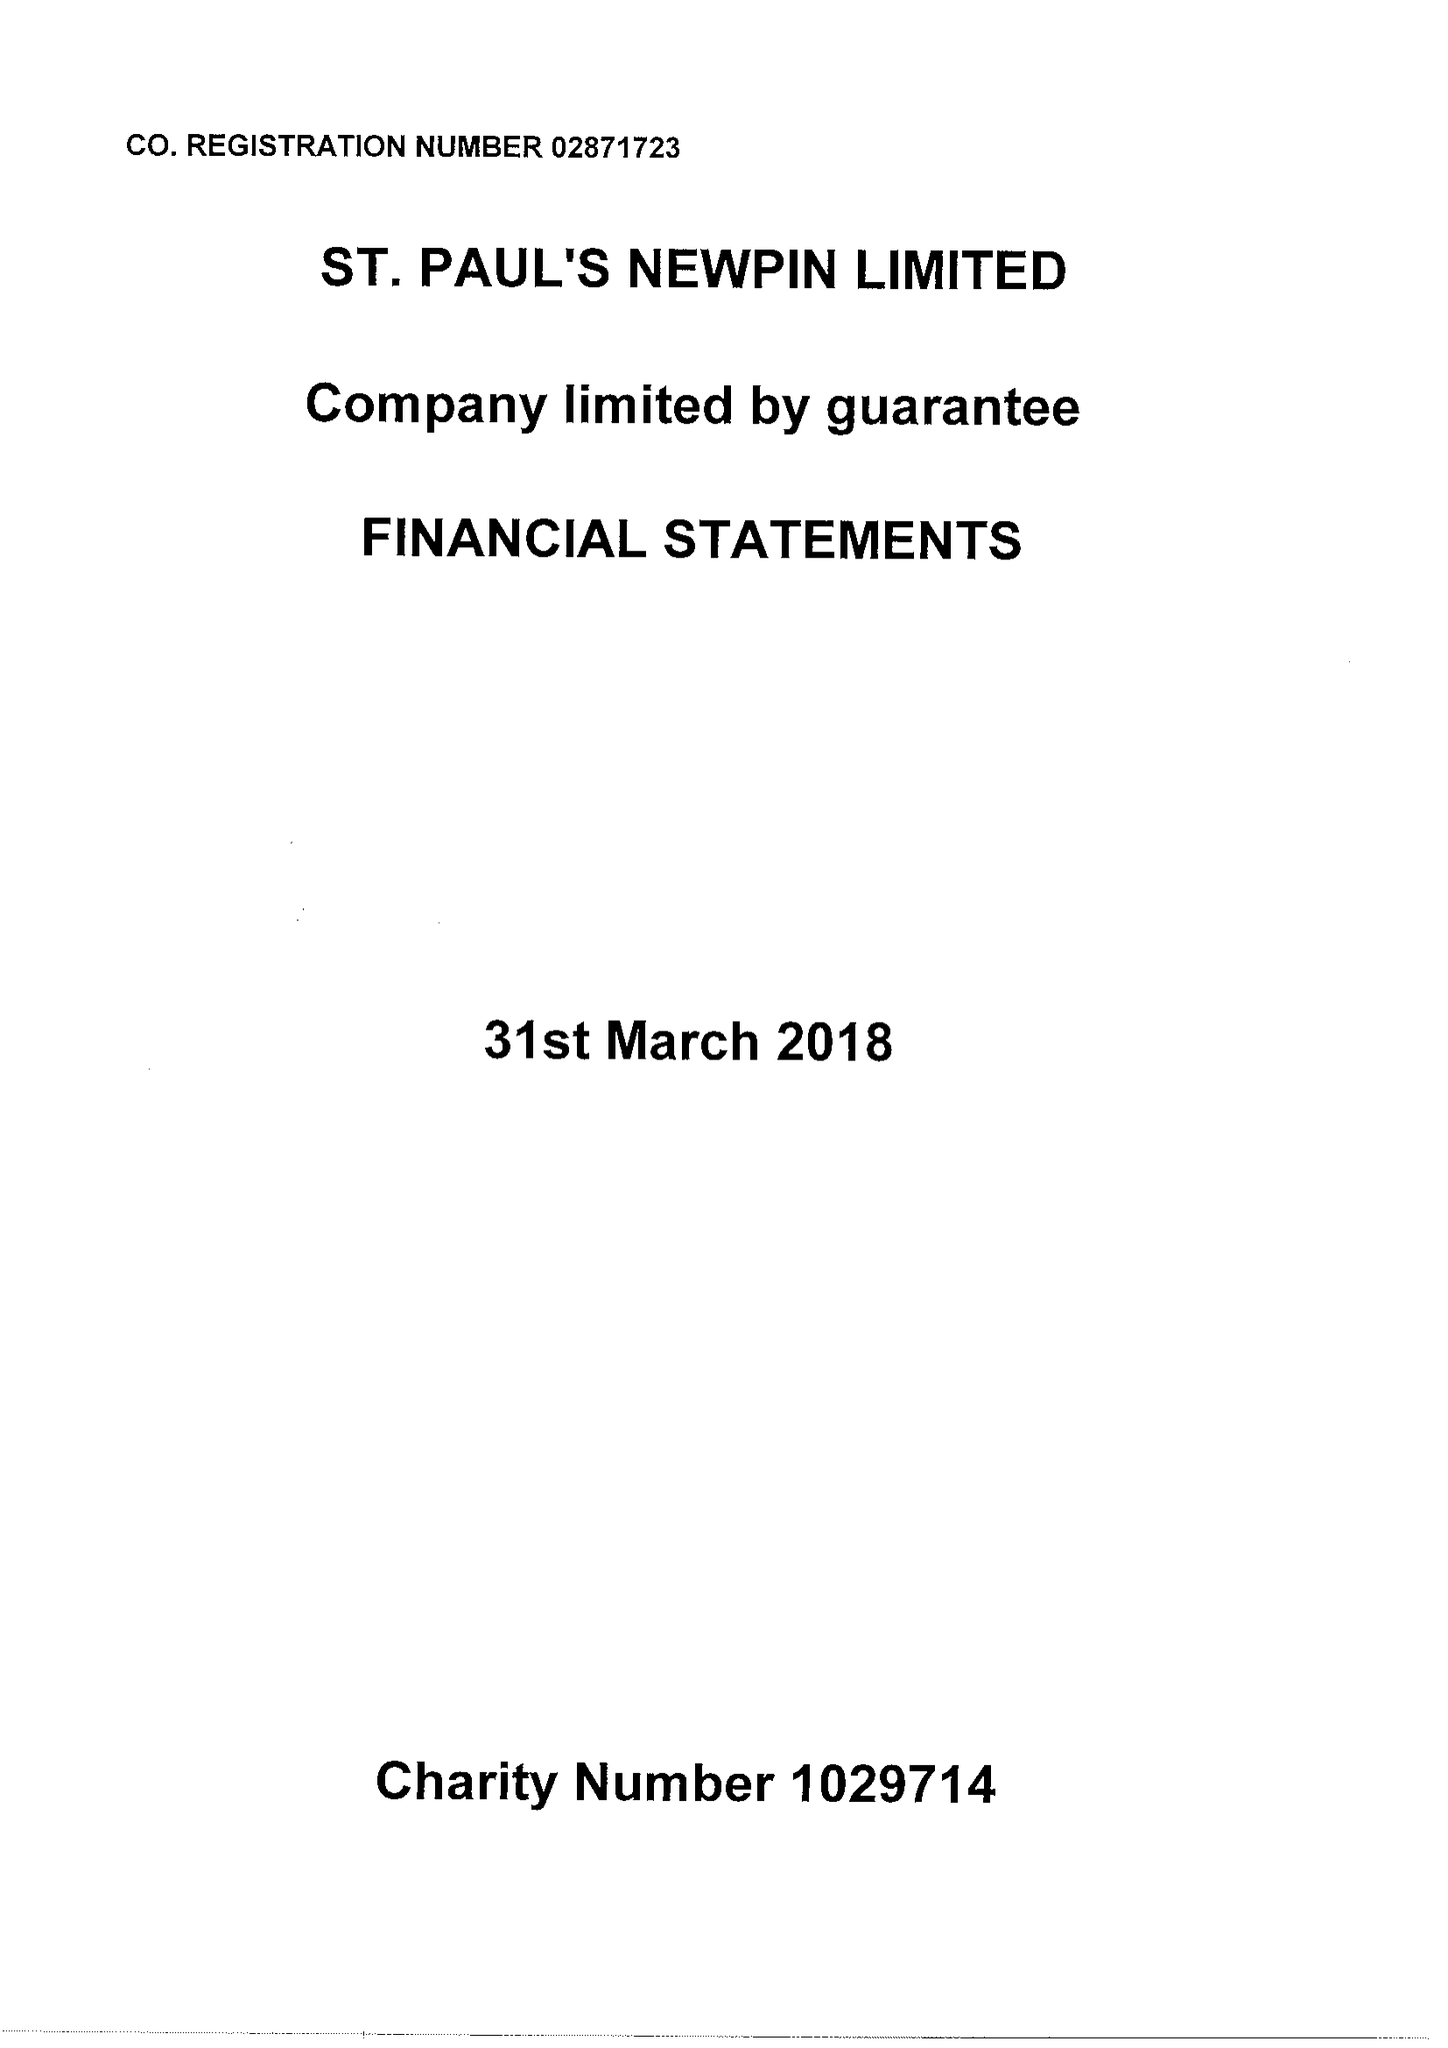What is the value for the address__street_line?
Answer the question using a single word or phrase. GATEFORTH STREET 